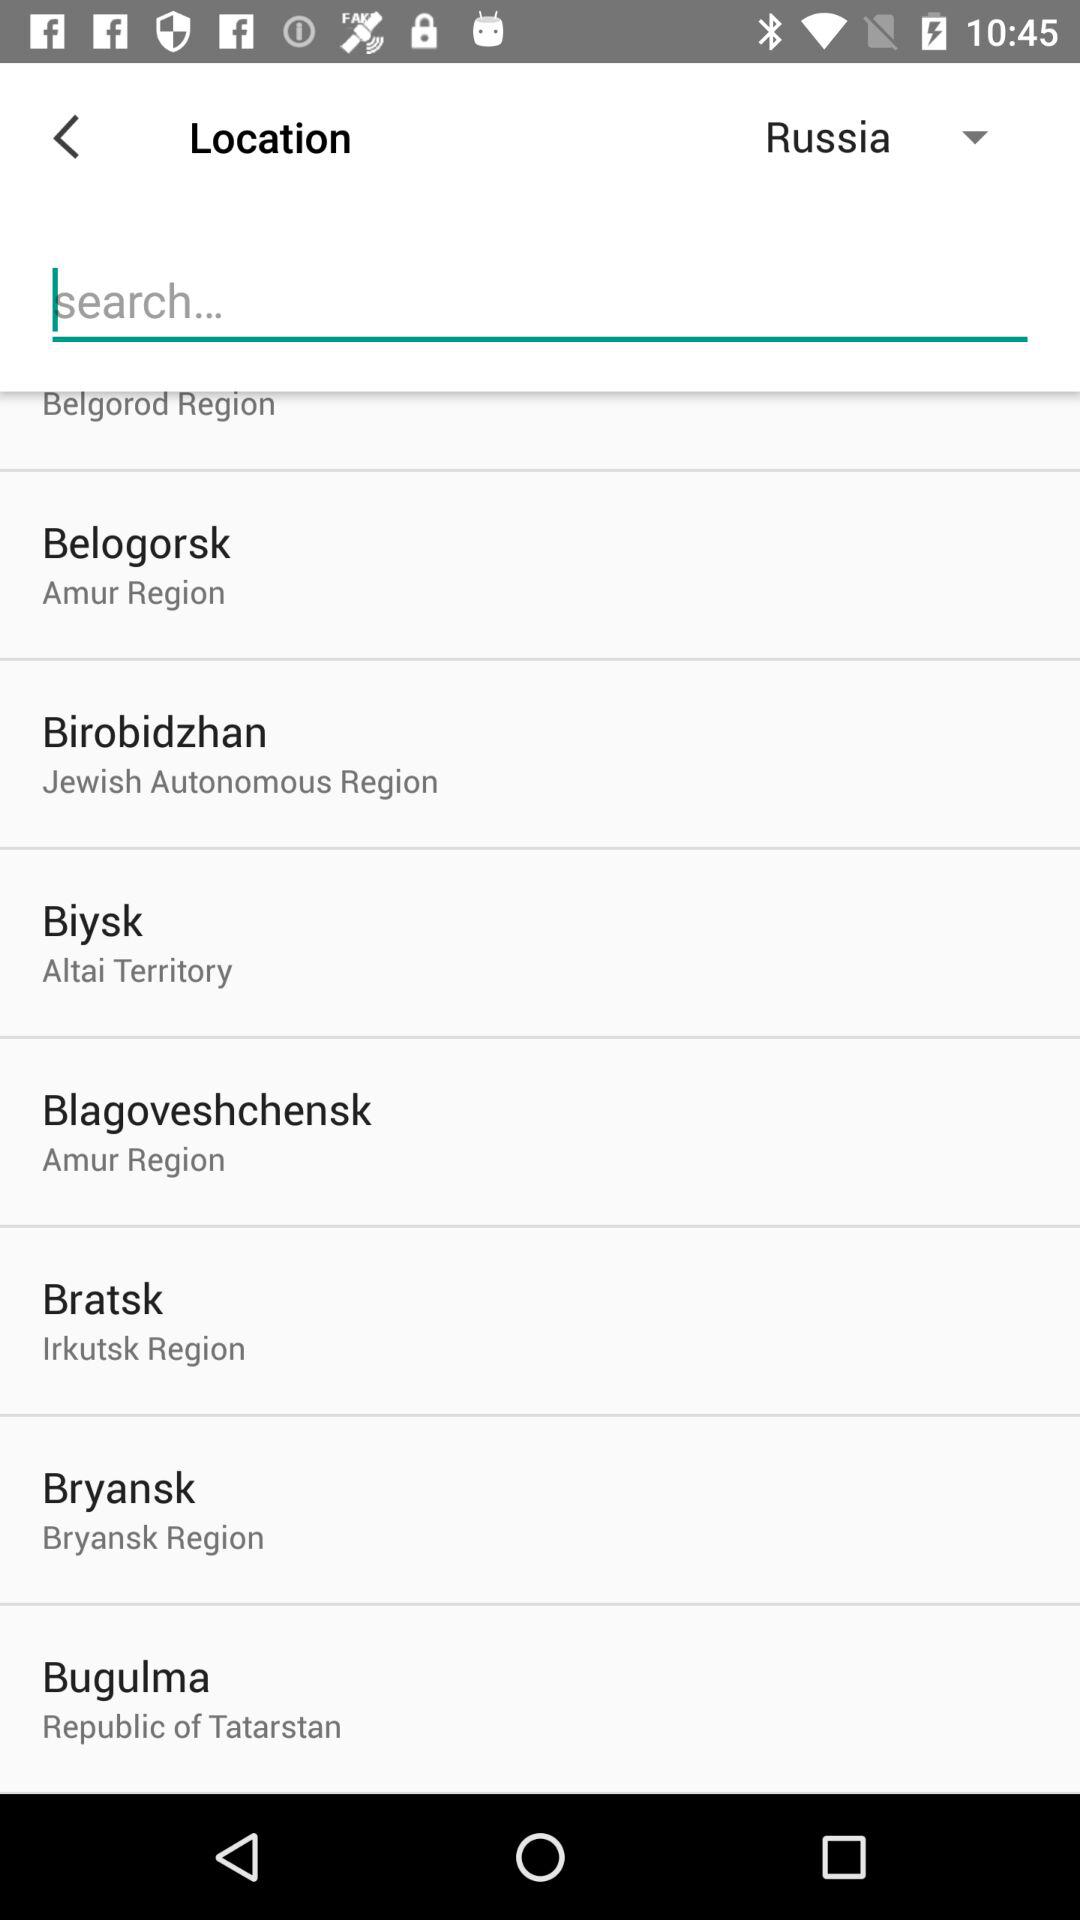Which countries are available in the drop-down menu?
When the provided information is insufficient, respond with <no answer>. <no answer> 